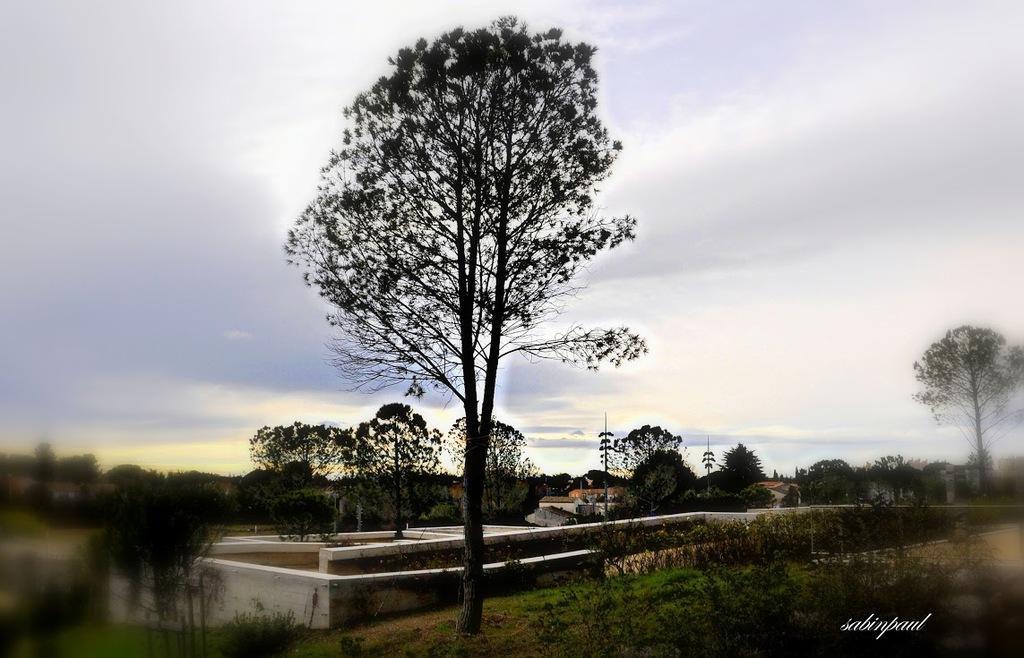Could you give a brief overview of what you see in this image? In this image we can see many trees. Also there are walls. On the ground there is grass. In the background there is sky. In the right bottom corner there is watermark. 